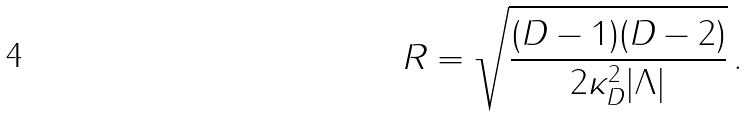Convert formula to latex. <formula><loc_0><loc_0><loc_500><loc_500>R = \sqrt { \frac { ( D - 1 ) ( D - 2 ) } { 2 \kappa ^ { 2 } _ { D } | \Lambda | } } \, .</formula> 